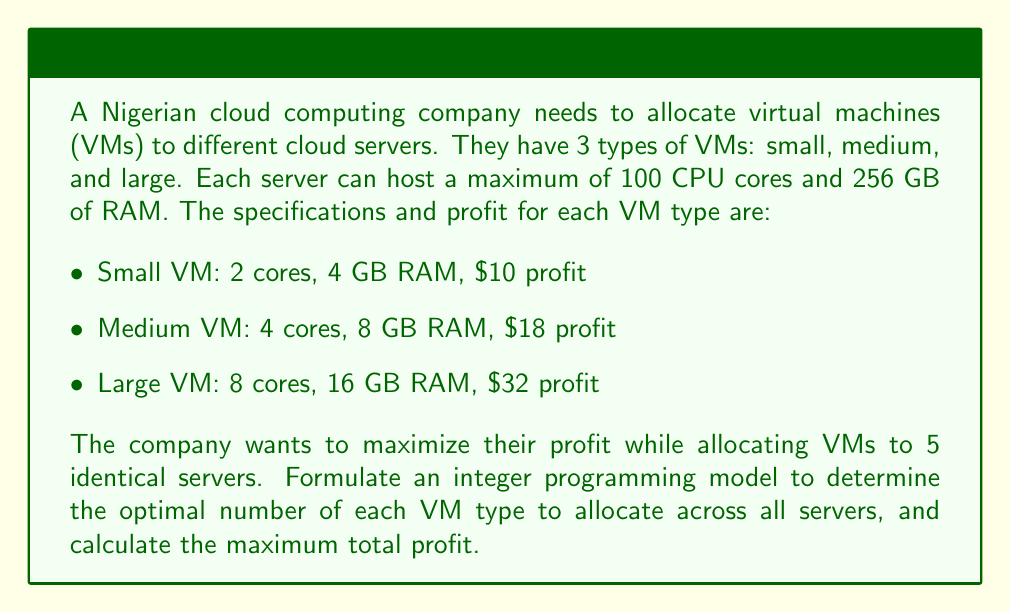Provide a solution to this math problem. Let's approach this step-by-step:

1. Define decision variables:
   Let $x_1$, $x_2$, and $x_3$ be the number of small, medium, and large VMs respectively.

2. Objective function:
   Maximize profit: $\max Z = 10x_1 + 18x_2 + 32x_3$

3. Constraints:
   a) CPU constraint (for 5 servers):
      $$(2x_1 + 4x_2 + 8x_3) \leq 5 \times 100 = 500$$
   
   b) RAM constraint (for 5 servers):
      $$(4x_1 + 8x_2 + 16x_3) \leq 5 \times 256 = 1280$$
   
   c) Non-negativity and integer constraints:
      $$x_1, x_2, x_3 \geq 0 \text{ and integer}$$

4. Solve the integer programming problem:
   We can use a solver or the branch and bound method to solve this. The optimal solution is:
   $$x_1 = 0, x_2 = 125, x_3 = 0$$

5. Calculate the maximum profit:
   $$Z = 10(0) + 18(125) + 32(0) = 2250$$

Therefore, the optimal allocation is to use 125 medium VMs across all 5 servers, resulting in a maximum profit of $2250.

To verify:
- CPU usage: $4 \times 125 = 500$ cores (exactly at capacity)
- RAM usage: $8 \times 125 = 1000$ GB (within the 1280 GB limit)
Answer: The optimal solution is to allocate 125 medium VMs across all servers, resulting in a maximum profit of $2250. 